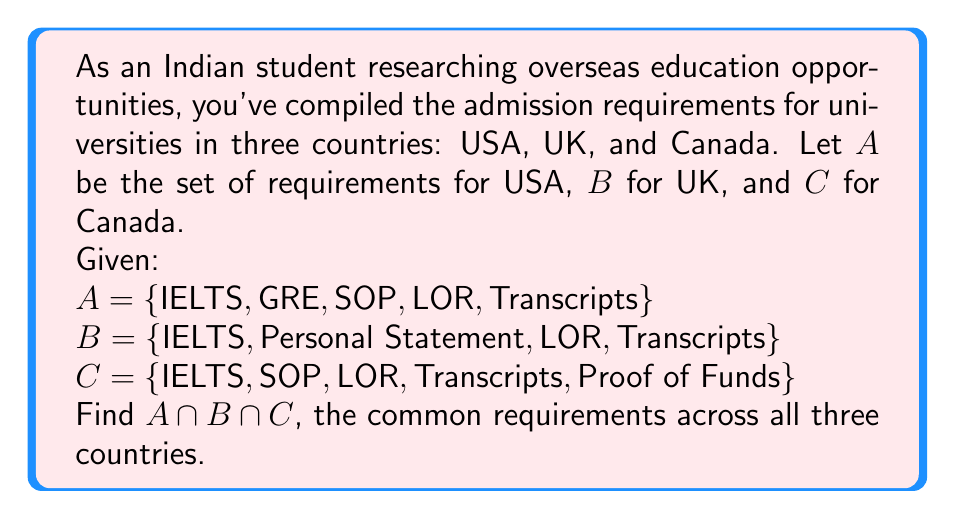Teach me how to tackle this problem. To find the intersection of the three sets, we need to identify the elements that are common to all three sets. Let's approach this step-by-step:

1. First, let's list out each set:
   A = {IELTS, GRE, SOP, LOR, Transcripts}
   B = {IELTS, Personal Statement, LOR, Transcripts}
   C = {IELTS, SOP, LOR, Transcripts, Proof of Funds}

2. Now, we need to find elements that appear in all three sets. We can do this by checking each element:

   - IELTS: Present in A, B, and C
   - GRE: Only in A
   - SOP: In A and C, but not in B
   - LOR: Present in A, B, and C
   - Transcripts: Present in A, B, and C
   - Personal Statement: Only in B
   - Proof of Funds: Only in C

3. The elements that appear in all three sets are:
   {IELTS, LOR, Transcripts}

4. Therefore, $A \cap B \cap C = \{IELTS, LOR, Transcripts\}$

This result shows that IELTS scores, Letters of Recommendation (LOR), and academic Transcripts are common requirements across universities in the USA, UK, and Canada.
Answer: $A \cap B \cap C = \{IELTS, LOR, Transcripts\}$ 